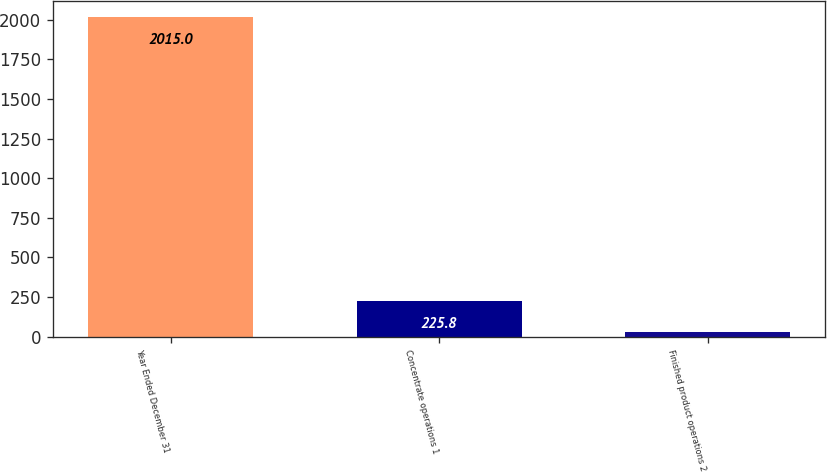<chart> <loc_0><loc_0><loc_500><loc_500><bar_chart><fcel>Year Ended December 31<fcel>Concentrate operations 1<fcel>Finished product operations 2<nl><fcel>2015<fcel>225.8<fcel>27<nl></chart> 